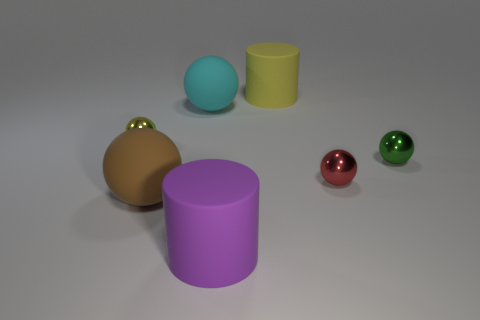There is a small ball that is left of the yellow object right of the purple rubber cylinder; what color is it?
Your answer should be compact. Yellow. What material is the tiny ball that is to the left of the rubber cylinder on the left side of the cylinder that is behind the yellow metal thing?
Provide a short and direct response. Metal. How many brown objects have the same size as the cyan thing?
Your answer should be compact. 1. There is a tiny thing that is both on the left side of the green metallic sphere and behind the red thing; what is it made of?
Provide a short and direct response. Metal. There is a big brown ball; what number of cylinders are behind it?
Offer a terse response. 1. Does the large yellow matte thing have the same shape as the thing in front of the large brown rubber thing?
Your answer should be compact. Yes. Is there another tiny red metal object that has the same shape as the small red metal thing?
Your answer should be compact. No. There is a shiny thing that is left of the cylinder behind the small green sphere; what is its shape?
Ensure brevity in your answer.  Sphere. There is a rubber object that is on the left side of the big cyan sphere; what is its shape?
Your answer should be very brief. Sphere. There is a tiny metallic ball that is behind the green thing; is its color the same as the big matte cylinder to the right of the big purple object?
Offer a very short reply. Yes. 